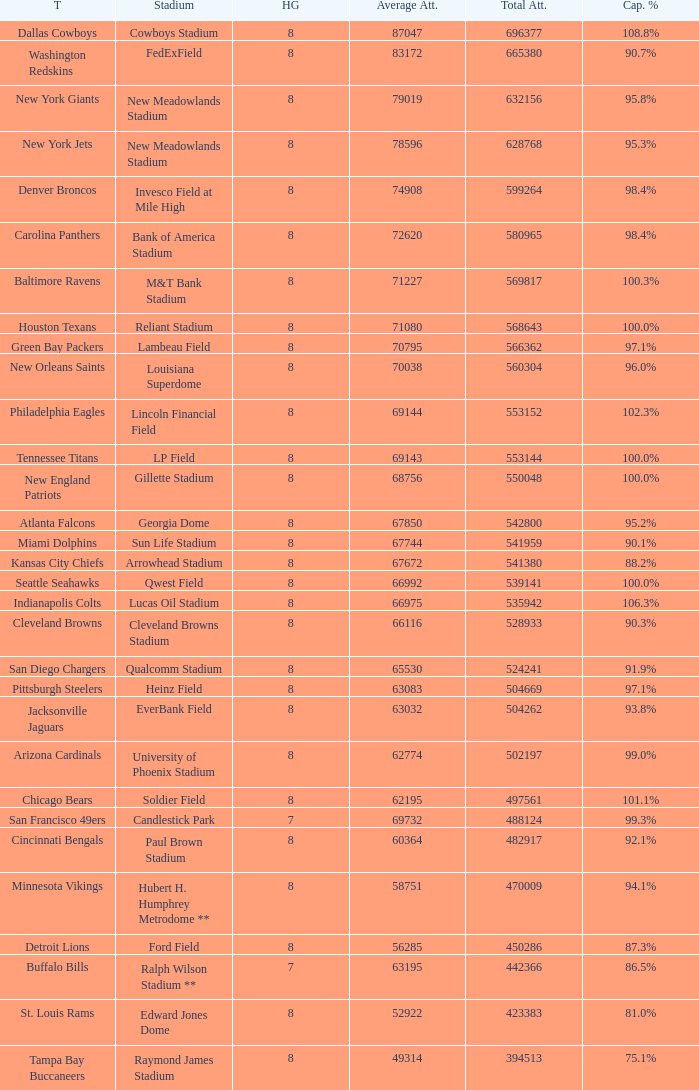How many teams had a 99.3% capacity rating? 1.0. Could you parse the entire table? {'header': ['T', 'Stadium', 'HG', 'Average Att.', 'Total Att.', 'Cap. %'], 'rows': [['Dallas Cowboys', 'Cowboys Stadium', '8', '87047', '696377', '108.8%'], ['Washington Redskins', 'FedExField', '8', '83172', '665380', '90.7%'], ['New York Giants', 'New Meadowlands Stadium', '8', '79019', '632156', '95.8%'], ['New York Jets', 'New Meadowlands Stadium', '8', '78596', '628768', '95.3%'], ['Denver Broncos', 'Invesco Field at Mile High', '8', '74908', '599264', '98.4%'], ['Carolina Panthers', 'Bank of America Stadium', '8', '72620', '580965', '98.4%'], ['Baltimore Ravens', 'M&T Bank Stadium', '8', '71227', '569817', '100.3%'], ['Houston Texans', 'Reliant Stadium', '8', '71080', '568643', '100.0%'], ['Green Bay Packers', 'Lambeau Field', '8', '70795', '566362', '97.1%'], ['New Orleans Saints', 'Louisiana Superdome', '8', '70038', '560304', '96.0%'], ['Philadelphia Eagles', 'Lincoln Financial Field', '8', '69144', '553152', '102.3%'], ['Tennessee Titans', 'LP Field', '8', '69143', '553144', '100.0%'], ['New England Patriots', 'Gillette Stadium', '8', '68756', '550048', '100.0%'], ['Atlanta Falcons', 'Georgia Dome', '8', '67850', '542800', '95.2%'], ['Miami Dolphins', 'Sun Life Stadium', '8', '67744', '541959', '90.1%'], ['Kansas City Chiefs', 'Arrowhead Stadium', '8', '67672', '541380', '88.2%'], ['Seattle Seahawks', 'Qwest Field', '8', '66992', '539141', '100.0%'], ['Indianapolis Colts', 'Lucas Oil Stadium', '8', '66975', '535942', '106.3%'], ['Cleveland Browns', 'Cleveland Browns Stadium', '8', '66116', '528933', '90.3%'], ['San Diego Chargers', 'Qualcomm Stadium', '8', '65530', '524241', '91.9%'], ['Pittsburgh Steelers', 'Heinz Field', '8', '63083', '504669', '97.1%'], ['Jacksonville Jaguars', 'EverBank Field', '8', '63032', '504262', '93.8%'], ['Arizona Cardinals', 'University of Phoenix Stadium', '8', '62774', '502197', '99.0%'], ['Chicago Bears', 'Soldier Field', '8', '62195', '497561', '101.1%'], ['San Francisco 49ers', 'Candlestick Park', '7', '69732', '488124', '99.3%'], ['Cincinnati Bengals', 'Paul Brown Stadium', '8', '60364', '482917', '92.1%'], ['Minnesota Vikings', 'Hubert H. Humphrey Metrodome **', '8', '58751', '470009', '94.1%'], ['Detroit Lions', 'Ford Field', '8', '56285', '450286', '87.3%'], ['Buffalo Bills', 'Ralph Wilson Stadium **', '7', '63195', '442366', '86.5%'], ['St. Louis Rams', 'Edward Jones Dome', '8', '52922', '423383', '81.0%'], ['Tampa Bay Buccaneers', 'Raymond James Stadium', '8', '49314', '394513', '75.1%']]} 